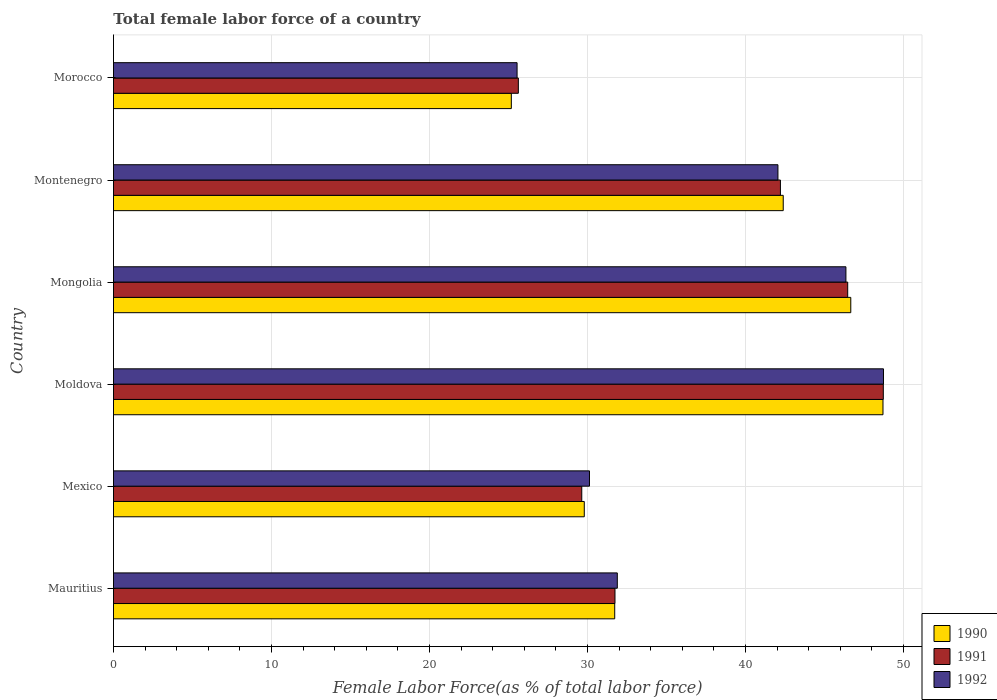Are the number of bars per tick equal to the number of legend labels?
Offer a terse response. Yes. What is the label of the 1st group of bars from the top?
Your response must be concise. Morocco. What is the percentage of female labor force in 1991 in Moldova?
Your answer should be very brief. 48.73. Across all countries, what is the maximum percentage of female labor force in 1992?
Your response must be concise. 48.74. Across all countries, what is the minimum percentage of female labor force in 1992?
Your response must be concise. 25.55. In which country was the percentage of female labor force in 1990 maximum?
Offer a very short reply. Moldova. In which country was the percentage of female labor force in 1991 minimum?
Provide a short and direct response. Morocco. What is the total percentage of female labor force in 1990 in the graph?
Provide a short and direct response. 224.48. What is the difference between the percentage of female labor force in 1992 in Mauritius and that in Morocco?
Your response must be concise. 6.35. What is the difference between the percentage of female labor force in 1992 in Morocco and the percentage of female labor force in 1990 in Mexico?
Your answer should be compact. -4.25. What is the average percentage of female labor force in 1992 per country?
Your answer should be compact. 37.45. What is the difference between the percentage of female labor force in 1990 and percentage of female labor force in 1991 in Mongolia?
Provide a short and direct response. 0.19. What is the ratio of the percentage of female labor force in 1992 in Mongolia to that in Morocco?
Offer a very short reply. 1.81. What is the difference between the highest and the second highest percentage of female labor force in 1991?
Your response must be concise. 2.25. What is the difference between the highest and the lowest percentage of female labor force in 1991?
Provide a short and direct response. 23.1. Is the sum of the percentage of female labor force in 1992 in Mexico and Morocco greater than the maximum percentage of female labor force in 1990 across all countries?
Offer a very short reply. Yes. What does the 1st bar from the top in Mauritius represents?
Offer a very short reply. 1992. How many bars are there?
Give a very brief answer. 18. Does the graph contain any zero values?
Your answer should be compact. No. How many legend labels are there?
Your response must be concise. 3. How are the legend labels stacked?
Provide a short and direct response. Vertical. What is the title of the graph?
Keep it short and to the point. Total female labor force of a country. What is the label or title of the X-axis?
Your answer should be very brief. Female Labor Force(as % of total labor force). What is the label or title of the Y-axis?
Offer a terse response. Country. What is the Female Labor Force(as % of total labor force) in 1990 in Mauritius?
Your response must be concise. 31.73. What is the Female Labor Force(as % of total labor force) of 1991 in Mauritius?
Ensure brevity in your answer.  31.74. What is the Female Labor Force(as % of total labor force) of 1992 in Mauritius?
Keep it short and to the point. 31.89. What is the Female Labor Force(as % of total labor force) in 1990 in Mexico?
Your answer should be very brief. 29.8. What is the Female Labor Force(as % of total labor force) of 1991 in Mexico?
Ensure brevity in your answer.  29.64. What is the Female Labor Force(as % of total labor force) of 1992 in Mexico?
Offer a very short reply. 30.13. What is the Female Labor Force(as % of total labor force) in 1990 in Moldova?
Make the answer very short. 48.71. What is the Female Labor Force(as % of total labor force) of 1991 in Moldova?
Give a very brief answer. 48.73. What is the Female Labor Force(as % of total labor force) in 1992 in Moldova?
Make the answer very short. 48.74. What is the Female Labor Force(as % of total labor force) in 1990 in Mongolia?
Provide a short and direct response. 46.67. What is the Female Labor Force(as % of total labor force) in 1991 in Mongolia?
Your response must be concise. 46.47. What is the Female Labor Force(as % of total labor force) in 1992 in Mongolia?
Offer a terse response. 46.36. What is the Female Labor Force(as % of total labor force) in 1990 in Montenegro?
Keep it short and to the point. 42.39. What is the Female Labor Force(as % of total labor force) of 1991 in Montenegro?
Your answer should be very brief. 42.22. What is the Female Labor Force(as % of total labor force) in 1992 in Montenegro?
Your response must be concise. 42.06. What is the Female Labor Force(as % of total labor force) in 1990 in Morocco?
Your response must be concise. 25.18. What is the Female Labor Force(as % of total labor force) of 1991 in Morocco?
Give a very brief answer. 25.63. What is the Female Labor Force(as % of total labor force) in 1992 in Morocco?
Offer a terse response. 25.55. Across all countries, what is the maximum Female Labor Force(as % of total labor force) in 1990?
Ensure brevity in your answer.  48.71. Across all countries, what is the maximum Female Labor Force(as % of total labor force) in 1991?
Offer a terse response. 48.73. Across all countries, what is the maximum Female Labor Force(as % of total labor force) of 1992?
Your answer should be compact. 48.74. Across all countries, what is the minimum Female Labor Force(as % of total labor force) of 1990?
Offer a terse response. 25.18. Across all countries, what is the minimum Female Labor Force(as % of total labor force) of 1991?
Make the answer very short. 25.63. Across all countries, what is the minimum Female Labor Force(as % of total labor force) in 1992?
Keep it short and to the point. 25.55. What is the total Female Labor Force(as % of total labor force) in 1990 in the graph?
Ensure brevity in your answer.  224.48. What is the total Female Labor Force(as % of total labor force) in 1991 in the graph?
Offer a terse response. 224.43. What is the total Female Labor Force(as % of total labor force) in 1992 in the graph?
Give a very brief answer. 224.73. What is the difference between the Female Labor Force(as % of total labor force) in 1990 in Mauritius and that in Mexico?
Provide a short and direct response. 1.93. What is the difference between the Female Labor Force(as % of total labor force) in 1991 in Mauritius and that in Mexico?
Offer a terse response. 2.1. What is the difference between the Female Labor Force(as % of total labor force) in 1992 in Mauritius and that in Mexico?
Provide a succinct answer. 1.76. What is the difference between the Female Labor Force(as % of total labor force) in 1990 in Mauritius and that in Moldova?
Offer a terse response. -16.98. What is the difference between the Female Labor Force(as % of total labor force) in 1991 in Mauritius and that in Moldova?
Your answer should be compact. -16.98. What is the difference between the Female Labor Force(as % of total labor force) of 1992 in Mauritius and that in Moldova?
Keep it short and to the point. -16.85. What is the difference between the Female Labor Force(as % of total labor force) in 1990 in Mauritius and that in Mongolia?
Give a very brief answer. -14.94. What is the difference between the Female Labor Force(as % of total labor force) in 1991 in Mauritius and that in Mongolia?
Provide a short and direct response. -14.73. What is the difference between the Female Labor Force(as % of total labor force) of 1992 in Mauritius and that in Mongolia?
Provide a short and direct response. -14.47. What is the difference between the Female Labor Force(as % of total labor force) in 1990 in Mauritius and that in Montenegro?
Give a very brief answer. -10.67. What is the difference between the Female Labor Force(as % of total labor force) in 1991 in Mauritius and that in Montenegro?
Your answer should be compact. -10.47. What is the difference between the Female Labor Force(as % of total labor force) in 1992 in Mauritius and that in Montenegro?
Your answer should be very brief. -10.17. What is the difference between the Female Labor Force(as % of total labor force) of 1990 in Mauritius and that in Morocco?
Provide a succinct answer. 6.54. What is the difference between the Female Labor Force(as % of total labor force) of 1991 in Mauritius and that in Morocco?
Offer a very short reply. 6.12. What is the difference between the Female Labor Force(as % of total labor force) of 1992 in Mauritius and that in Morocco?
Offer a very short reply. 6.35. What is the difference between the Female Labor Force(as % of total labor force) in 1990 in Mexico and that in Moldova?
Your answer should be compact. -18.91. What is the difference between the Female Labor Force(as % of total labor force) of 1991 in Mexico and that in Moldova?
Offer a very short reply. -19.09. What is the difference between the Female Labor Force(as % of total labor force) of 1992 in Mexico and that in Moldova?
Your answer should be compact. -18.61. What is the difference between the Female Labor Force(as % of total labor force) of 1990 in Mexico and that in Mongolia?
Keep it short and to the point. -16.87. What is the difference between the Female Labor Force(as % of total labor force) in 1991 in Mexico and that in Mongolia?
Your answer should be compact. -16.83. What is the difference between the Female Labor Force(as % of total labor force) of 1992 in Mexico and that in Mongolia?
Your response must be concise. -16.23. What is the difference between the Female Labor Force(as % of total labor force) of 1990 in Mexico and that in Montenegro?
Give a very brief answer. -12.59. What is the difference between the Female Labor Force(as % of total labor force) of 1991 in Mexico and that in Montenegro?
Keep it short and to the point. -12.57. What is the difference between the Female Labor Force(as % of total labor force) in 1992 in Mexico and that in Montenegro?
Make the answer very short. -11.93. What is the difference between the Female Labor Force(as % of total labor force) in 1990 in Mexico and that in Morocco?
Your response must be concise. 4.62. What is the difference between the Female Labor Force(as % of total labor force) in 1991 in Mexico and that in Morocco?
Make the answer very short. 4.01. What is the difference between the Female Labor Force(as % of total labor force) of 1992 in Mexico and that in Morocco?
Provide a short and direct response. 4.58. What is the difference between the Female Labor Force(as % of total labor force) of 1990 in Moldova and that in Mongolia?
Give a very brief answer. 2.04. What is the difference between the Female Labor Force(as % of total labor force) in 1991 in Moldova and that in Mongolia?
Make the answer very short. 2.25. What is the difference between the Female Labor Force(as % of total labor force) of 1992 in Moldova and that in Mongolia?
Offer a terse response. 2.38. What is the difference between the Female Labor Force(as % of total labor force) in 1990 in Moldova and that in Montenegro?
Offer a terse response. 6.31. What is the difference between the Female Labor Force(as % of total labor force) in 1991 in Moldova and that in Montenegro?
Provide a succinct answer. 6.51. What is the difference between the Female Labor Force(as % of total labor force) of 1992 in Moldova and that in Montenegro?
Provide a succinct answer. 6.68. What is the difference between the Female Labor Force(as % of total labor force) of 1990 in Moldova and that in Morocco?
Provide a short and direct response. 23.53. What is the difference between the Female Labor Force(as % of total labor force) in 1991 in Moldova and that in Morocco?
Make the answer very short. 23.1. What is the difference between the Female Labor Force(as % of total labor force) in 1992 in Moldova and that in Morocco?
Keep it short and to the point. 23.19. What is the difference between the Female Labor Force(as % of total labor force) in 1990 in Mongolia and that in Montenegro?
Your answer should be compact. 4.28. What is the difference between the Female Labor Force(as % of total labor force) in 1991 in Mongolia and that in Montenegro?
Provide a succinct answer. 4.26. What is the difference between the Female Labor Force(as % of total labor force) in 1992 in Mongolia and that in Montenegro?
Give a very brief answer. 4.3. What is the difference between the Female Labor Force(as % of total labor force) of 1990 in Mongolia and that in Morocco?
Provide a short and direct response. 21.49. What is the difference between the Female Labor Force(as % of total labor force) of 1991 in Mongolia and that in Morocco?
Offer a terse response. 20.85. What is the difference between the Female Labor Force(as % of total labor force) in 1992 in Mongolia and that in Morocco?
Make the answer very short. 20.82. What is the difference between the Female Labor Force(as % of total labor force) in 1990 in Montenegro and that in Morocco?
Offer a terse response. 17.21. What is the difference between the Female Labor Force(as % of total labor force) in 1991 in Montenegro and that in Morocco?
Your answer should be compact. 16.59. What is the difference between the Female Labor Force(as % of total labor force) of 1992 in Montenegro and that in Morocco?
Keep it short and to the point. 16.51. What is the difference between the Female Labor Force(as % of total labor force) of 1990 in Mauritius and the Female Labor Force(as % of total labor force) of 1991 in Mexico?
Provide a short and direct response. 2.09. What is the difference between the Female Labor Force(as % of total labor force) of 1990 in Mauritius and the Female Labor Force(as % of total labor force) of 1992 in Mexico?
Your response must be concise. 1.6. What is the difference between the Female Labor Force(as % of total labor force) in 1991 in Mauritius and the Female Labor Force(as % of total labor force) in 1992 in Mexico?
Give a very brief answer. 1.61. What is the difference between the Female Labor Force(as % of total labor force) in 1990 in Mauritius and the Female Labor Force(as % of total labor force) in 1991 in Moldova?
Your response must be concise. -17. What is the difference between the Female Labor Force(as % of total labor force) in 1990 in Mauritius and the Female Labor Force(as % of total labor force) in 1992 in Moldova?
Keep it short and to the point. -17.01. What is the difference between the Female Labor Force(as % of total labor force) in 1991 in Mauritius and the Female Labor Force(as % of total labor force) in 1992 in Moldova?
Your response must be concise. -17. What is the difference between the Female Labor Force(as % of total labor force) of 1990 in Mauritius and the Female Labor Force(as % of total labor force) of 1991 in Mongolia?
Keep it short and to the point. -14.75. What is the difference between the Female Labor Force(as % of total labor force) of 1990 in Mauritius and the Female Labor Force(as % of total labor force) of 1992 in Mongolia?
Keep it short and to the point. -14.63. What is the difference between the Female Labor Force(as % of total labor force) in 1991 in Mauritius and the Female Labor Force(as % of total labor force) in 1992 in Mongolia?
Your response must be concise. -14.62. What is the difference between the Female Labor Force(as % of total labor force) in 1990 in Mauritius and the Female Labor Force(as % of total labor force) in 1991 in Montenegro?
Provide a short and direct response. -10.49. What is the difference between the Female Labor Force(as % of total labor force) of 1990 in Mauritius and the Female Labor Force(as % of total labor force) of 1992 in Montenegro?
Give a very brief answer. -10.33. What is the difference between the Female Labor Force(as % of total labor force) of 1991 in Mauritius and the Female Labor Force(as % of total labor force) of 1992 in Montenegro?
Ensure brevity in your answer.  -10.31. What is the difference between the Female Labor Force(as % of total labor force) in 1990 in Mauritius and the Female Labor Force(as % of total labor force) in 1991 in Morocco?
Offer a very short reply. 6.1. What is the difference between the Female Labor Force(as % of total labor force) of 1990 in Mauritius and the Female Labor Force(as % of total labor force) of 1992 in Morocco?
Give a very brief answer. 6.18. What is the difference between the Female Labor Force(as % of total labor force) in 1991 in Mauritius and the Female Labor Force(as % of total labor force) in 1992 in Morocco?
Provide a succinct answer. 6.2. What is the difference between the Female Labor Force(as % of total labor force) of 1990 in Mexico and the Female Labor Force(as % of total labor force) of 1991 in Moldova?
Your answer should be compact. -18.93. What is the difference between the Female Labor Force(as % of total labor force) in 1990 in Mexico and the Female Labor Force(as % of total labor force) in 1992 in Moldova?
Ensure brevity in your answer.  -18.94. What is the difference between the Female Labor Force(as % of total labor force) of 1991 in Mexico and the Female Labor Force(as % of total labor force) of 1992 in Moldova?
Provide a short and direct response. -19.1. What is the difference between the Female Labor Force(as % of total labor force) of 1990 in Mexico and the Female Labor Force(as % of total labor force) of 1991 in Mongolia?
Keep it short and to the point. -16.67. What is the difference between the Female Labor Force(as % of total labor force) of 1990 in Mexico and the Female Labor Force(as % of total labor force) of 1992 in Mongolia?
Ensure brevity in your answer.  -16.56. What is the difference between the Female Labor Force(as % of total labor force) of 1991 in Mexico and the Female Labor Force(as % of total labor force) of 1992 in Mongolia?
Offer a terse response. -16.72. What is the difference between the Female Labor Force(as % of total labor force) in 1990 in Mexico and the Female Labor Force(as % of total labor force) in 1991 in Montenegro?
Make the answer very short. -12.42. What is the difference between the Female Labor Force(as % of total labor force) of 1990 in Mexico and the Female Labor Force(as % of total labor force) of 1992 in Montenegro?
Offer a very short reply. -12.26. What is the difference between the Female Labor Force(as % of total labor force) in 1991 in Mexico and the Female Labor Force(as % of total labor force) in 1992 in Montenegro?
Make the answer very short. -12.42. What is the difference between the Female Labor Force(as % of total labor force) in 1990 in Mexico and the Female Labor Force(as % of total labor force) in 1991 in Morocco?
Make the answer very short. 4.17. What is the difference between the Female Labor Force(as % of total labor force) in 1990 in Mexico and the Female Labor Force(as % of total labor force) in 1992 in Morocco?
Make the answer very short. 4.25. What is the difference between the Female Labor Force(as % of total labor force) of 1991 in Mexico and the Female Labor Force(as % of total labor force) of 1992 in Morocco?
Keep it short and to the point. 4.09. What is the difference between the Female Labor Force(as % of total labor force) of 1990 in Moldova and the Female Labor Force(as % of total labor force) of 1991 in Mongolia?
Your response must be concise. 2.23. What is the difference between the Female Labor Force(as % of total labor force) in 1990 in Moldova and the Female Labor Force(as % of total labor force) in 1992 in Mongolia?
Give a very brief answer. 2.35. What is the difference between the Female Labor Force(as % of total labor force) in 1991 in Moldova and the Female Labor Force(as % of total labor force) in 1992 in Mongolia?
Ensure brevity in your answer.  2.37. What is the difference between the Female Labor Force(as % of total labor force) in 1990 in Moldova and the Female Labor Force(as % of total labor force) in 1991 in Montenegro?
Your response must be concise. 6.49. What is the difference between the Female Labor Force(as % of total labor force) in 1990 in Moldova and the Female Labor Force(as % of total labor force) in 1992 in Montenegro?
Give a very brief answer. 6.65. What is the difference between the Female Labor Force(as % of total labor force) of 1991 in Moldova and the Female Labor Force(as % of total labor force) of 1992 in Montenegro?
Offer a very short reply. 6.67. What is the difference between the Female Labor Force(as % of total labor force) in 1990 in Moldova and the Female Labor Force(as % of total labor force) in 1991 in Morocco?
Offer a very short reply. 23.08. What is the difference between the Female Labor Force(as % of total labor force) of 1990 in Moldova and the Female Labor Force(as % of total labor force) of 1992 in Morocco?
Offer a very short reply. 23.16. What is the difference between the Female Labor Force(as % of total labor force) of 1991 in Moldova and the Female Labor Force(as % of total labor force) of 1992 in Morocco?
Offer a terse response. 23.18. What is the difference between the Female Labor Force(as % of total labor force) in 1990 in Mongolia and the Female Labor Force(as % of total labor force) in 1991 in Montenegro?
Keep it short and to the point. 4.45. What is the difference between the Female Labor Force(as % of total labor force) in 1990 in Mongolia and the Female Labor Force(as % of total labor force) in 1992 in Montenegro?
Give a very brief answer. 4.61. What is the difference between the Female Labor Force(as % of total labor force) of 1991 in Mongolia and the Female Labor Force(as % of total labor force) of 1992 in Montenegro?
Offer a terse response. 4.42. What is the difference between the Female Labor Force(as % of total labor force) of 1990 in Mongolia and the Female Labor Force(as % of total labor force) of 1991 in Morocco?
Your answer should be very brief. 21.04. What is the difference between the Female Labor Force(as % of total labor force) in 1990 in Mongolia and the Female Labor Force(as % of total labor force) in 1992 in Morocco?
Ensure brevity in your answer.  21.12. What is the difference between the Female Labor Force(as % of total labor force) in 1991 in Mongolia and the Female Labor Force(as % of total labor force) in 1992 in Morocco?
Give a very brief answer. 20.93. What is the difference between the Female Labor Force(as % of total labor force) of 1990 in Montenegro and the Female Labor Force(as % of total labor force) of 1991 in Morocco?
Your response must be concise. 16.77. What is the difference between the Female Labor Force(as % of total labor force) of 1990 in Montenegro and the Female Labor Force(as % of total labor force) of 1992 in Morocco?
Make the answer very short. 16.85. What is the difference between the Female Labor Force(as % of total labor force) in 1991 in Montenegro and the Female Labor Force(as % of total labor force) in 1992 in Morocco?
Keep it short and to the point. 16.67. What is the average Female Labor Force(as % of total labor force) of 1990 per country?
Offer a terse response. 37.41. What is the average Female Labor Force(as % of total labor force) of 1991 per country?
Your answer should be very brief. 37.4. What is the average Female Labor Force(as % of total labor force) in 1992 per country?
Your answer should be very brief. 37.45. What is the difference between the Female Labor Force(as % of total labor force) of 1990 and Female Labor Force(as % of total labor force) of 1991 in Mauritius?
Keep it short and to the point. -0.02. What is the difference between the Female Labor Force(as % of total labor force) in 1990 and Female Labor Force(as % of total labor force) in 1992 in Mauritius?
Provide a succinct answer. -0.16. What is the difference between the Female Labor Force(as % of total labor force) of 1991 and Female Labor Force(as % of total labor force) of 1992 in Mauritius?
Provide a succinct answer. -0.15. What is the difference between the Female Labor Force(as % of total labor force) in 1990 and Female Labor Force(as % of total labor force) in 1991 in Mexico?
Offer a terse response. 0.16. What is the difference between the Female Labor Force(as % of total labor force) in 1990 and Female Labor Force(as % of total labor force) in 1992 in Mexico?
Provide a short and direct response. -0.33. What is the difference between the Female Labor Force(as % of total labor force) in 1991 and Female Labor Force(as % of total labor force) in 1992 in Mexico?
Your answer should be very brief. -0.49. What is the difference between the Female Labor Force(as % of total labor force) in 1990 and Female Labor Force(as % of total labor force) in 1991 in Moldova?
Make the answer very short. -0.02. What is the difference between the Female Labor Force(as % of total labor force) of 1990 and Female Labor Force(as % of total labor force) of 1992 in Moldova?
Offer a very short reply. -0.03. What is the difference between the Female Labor Force(as % of total labor force) in 1991 and Female Labor Force(as % of total labor force) in 1992 in Moldova?
Provide a short and direct response. -0.01. What is the difference between the Female Labor Force(as % of total labor force) in 1990 and Female Labor Force(as % of total labor force) in 1991 in Mongolia?
Offer a terse response. 0.19. What is the difference between the Female Labor Force(as % of total labor force) of 1990 and Female Labor Force(as % of total labor force) of 1992 in Mongolia?
Your answer should be very brief. 0.31. What is the difference between the Female Labor Force(as % of total labor force) in 1991 and Female Labor Force(as % of total labor force) in 1992 in Mongolia?
Offer a terse response. 0.11. What is the difference between the Female Labor Force(as % of total labor force) of 1990 and Female Labor Force(as % of total labor force) of 1991 in Montenegro?
Your answer should be very brief. 0.18. What is the difference between the Female Labor Force(as % of total labor force) in 1990 and Female Labor Force(as % of total labor force) in 1992 in Montenegro?
Make the answer very short. 0.33. What is the difference between the Female Labor Force(as % of total labor force) of 1991 and Female Labor Force(as % of total labor force) of 1992 in Montenegro?
Your answer should be compact. 0.16. What is the difference between the Female Labor Force(as % of total labor force) in 1990 and Female Labor Force(as % of total labor force) in 1991 in Morocco?
Give a very brief answer. -0.44. What is the difference between the Female Labor Force(as % of total labor force) of 1990 and Female Labor Force(as % of total labor force) of 1992 in Morocco?
Ensure brevity in your answer.  -0.36. What is the difference between the Female Labor Force(as % of total labor force) in 1991 and Female Labor Force(as % of total labor force) in 1992 in Morocco?
Provide a succinct answer. 0.08. What is the ratio of the Female Labor Force(as % of total labor force) in 1990 in Mauritius to that in Mexico?
Your response must be concise. 1.06. What is the ratio of the Female Labor Force(as % of total labor force) in 1991 in Mauritius to that in Mexico?
Make the answer very short. 1.07. What is the ratio of the Female Labor Force(as % of total labor force) of 1992 in Mauritius to that in Mexico?
Your answer should be very brief. 1.06. What is the ratio of the Female Labor Force(as % of total labor force) of 1990 in Mauritius to that in Moldova?
Offer a very short reply. 0.65. What is the ratio of the Female Labor Force(as % of total labor force) of 1991 in Mauritius to that in Moldova?
Your answer should be very brief. 0.65. What is the ratio of the Female Labor Force(as % of total labor force) in 1992 in Mauritius to that in Moldova?
Keep it short and to the point. 0.65. What is the ratio of the Female Labor Force(as % of total labor force) in 1990 in Mauritius to that in Mongolia?
Make the answer very short. 0.68. What is the ratio of the Female Labor Force(as % of total labor force) in 1991 in Mauritius to that in Mongolia?
Keep it short and to the point. 0.68. What is the ratio of the Female Labor Force(as % of total labor force) of 1992 in Mauritius to that in Mongolia?
Your answer should be very brief. 0.69. What is the ratio of the Female Labor Force(as % of total labor force) of 1990 in Mauritius to that in Montenegro?
Give a very brief answer. 0.75. What is the ratio of the Female Labor Force(as % of total labor force) in 1991 in Mauritius to that in Montenegro?
Give a very brief answer. 0.75. What is the ratio of the Female Labor Force(as % of total labor force) of 1992 in Mauritius to that in Montenegro?
Keep it short and to the point. 0.76. What is the ratio of the Female Labor Force(as % of total labor force) of 1990 in Mauritius to that in Morocco?
Give a very brief answer. 1.26. What is the ratio of the Female Labor Force(as % of total labor force) in 1991 in Mauritius to that in Morocco?
Give a very brief answer. 1.24. What is the ratio of the Female Labor Force(as % of total labor force) in 1992 in Mauritius to that in Morocco?
Offer a very short reply. 1.25. What is the ratio of the Female Labor Force(as % of total labor force) in 1990 in Mexico to that in Moldova?
Ensure brevity in your answer.  0.61. What is the ratio of the Female Labor Force(as % of total labor force) in 1991 in Mexico to that in Moldova?
Provide a short and direct response. 0.61. What is the ratio of the Female Labor Force(as % of total labor force) in 1992 in Mexico to that in Moldova?
Provide a succinct answer. 0.62. What is the ratio of the Female Labor Force(as % of total labor force) of 1990 in Mexico to that in Mongolia?
Make the answer very short. 0.64. What is the ratio of the Female Labor Force(as % of total labor force) in 1991 in Mexico to that in Mongolia?
Your answer should be compact. 0.64. What is the ratio of the Female Labor Force(as % of total labor force) in 1992 in Mexico to that in Mongolia?
Your answer should be very brief. 0.65. What is the ratio of the Female Labor Force(as % of total labor force) in 1990 in Mexico to that in Montenegro?
Make the answer very short. 0.7. What is the ratio of the Female Labor Force(as % of total labor force) of 1991 in Mexico to that in Montenegro?
Give a very brief answer. 0.7. What is the ratio of the Female Labor Force(as % of total labor force) in 1992 in Mexico to that in Montenegro?
Offer a terse response. 0.72. What is the ratio of the Female Labor Force(as % of total labor force) of 1990 in Mexico to that in Morocco?
Provide a short and direct response. 1.18. What is the ratio of the Female Labor Force(as % of total labor force) of 1991 in Mexico to that in Morocco?
Give a very brief answer. 1.16. What is the ratio of the Female Labor Force(as % of total labor force) of 1992 in Mexico to that in Morocco?
Give a very brief answer. 1.18. What is the ratio of the Female Labor Force(as % of total labor force) of 1990 in Moldova to that in Mongolia?
Your answer should be compact. 1.04. What is the ratio of the Female Labor Force(as % of total labor force) of 1991 in Moldova to that in Mongolia?
Give a very brief answer. 1.05. What is the ratio of the Female Labor Force(as % of total labor force) of 1992 in Moldova to that in Mongolia?
Your answer should be compact. 1.05. What is the ratio of the Female Labor Force(as % of total labor force) in 1990 in Moldova to that in Montenegro?
Offer a terse response. 1.15. What is the ratio of the Female Labor Force(as % of total labor force) in 1991 in Moldova to that in Montenegro?
Give a very brief answer. 1.15. What is the ratio of the Female Labor Force(as % of total labor force) of 1992 in Moldova to that in Montenegro?
Your response must be concise. 1.16. What is the ratio of the Female Labor Force(as % of total labor force) of 1990 in Moldova to that in Morocco?
Make the answer very short. 1.93. What is the ratio of the Female Labor Force(as % of total labor force) in 1991 in Moldova to that in Morocco?
Offer a terse response. 1.9. What is the ratio of the Female Labor Force(as % of total labor force) in 1992 in Moldova to that in Morocco?
Offer a terse response. 1.91. What is the ratio of the Female Labor Force(as % of total labor force) in 1990 in Mongolia to that in Montenegro?
Provide a short and direct response. 1.1. What is the ratio of the Female Labor Force(as % of total labor force) in 1991 in Mongolia to that in Montenegro?
Offer a terse response. 1.1. What is the ratio of the Female Labor Force(as % of total labor force) in 1992 in Mongolia to that in Montenegro?
Your answer should be compact. 1.1. What is the ratio of the Female Labor Force(as % of total labor force) of 1990 in Mongolia to that in Morocco?
Make the answer very short. 1.85. What is the ratio of the Female Labor Force(as % of total labor force) in 1991 in Mongolia to that in Morocco?
Ensure brevity in your answer.  1.81. What is the ratio of the Female Labor Force(as % of total labor force) of 1992 in Mongolia to that in Morocco?
Make the answer very short. 1.81. What is the ratio of the Female Labor Force(as % of total labor force) of 1990 in Montenegro to that in Morocco?
Make the answer very short. 1.68. What is the ratio of the Female Labor Force(as % of total labor force) of 1991 in Montenegro to that in Morocco?
Offer a very short reply. 1.65. What is the ratio of the Female Labor Force(as % of total labor force) in 1992 in Montenegro to that in Morocco?
Make the answer very short. 1.65. What is the difference between the highest and the second highest Female Labor Force(as % of total labor force) in 1990?
Keep it short and to the point. 2.04. What is the difference between the highest and the second highest Female Labor Force(as % of total labor force) in 1991?
Offer a very short reply. 2.25. What is the difference between the highest and the second highest Female Labor Force(as % of total labor force) in 1992?
Provide a succinct answer. 2.38. What is the difference between the highest and the lowest Female Labor Force(as % of total labor force) of 1990?
Provide a short and direct response. 23.53. What is the difference between the highest and the lowest Female Labor Force(as % of total labor force) in 1991?
Your answer should be very brief. 23.1. What is the difference between the highest and the lowest Female Labor Force(as % of total labor force) in 1992?
Keep it short and to the point. 23.19. 